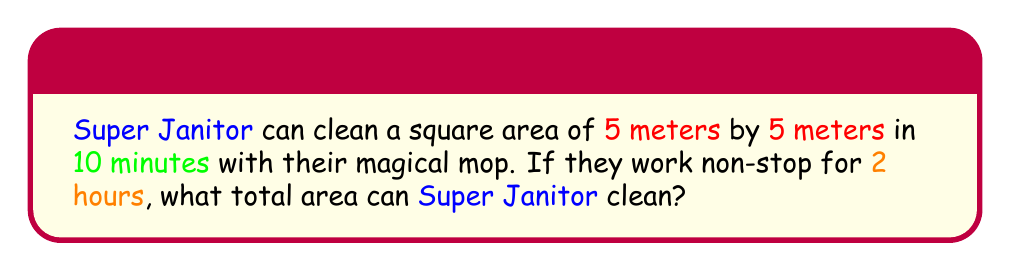Teach me how to tackle this problem. Let's break this down step-by-step:

1. First, we need to calculate the area Super Janitor can clean in 10 minutes:
   Area per 10 minutes = $5 \text{ m} \times 5 \text{ m} = 25 \text{ m}^2$

2. Now, let's convert 2 hours into minutes:
   $2 \text{ hours} = 2 \times 60 \text{ minutes} = 120 \text{ minutes}$

3. We need to find out how many 10-minute intervals are in 120 minutes:
   Number of intervals = $\frac{120 \text{ minutes}}{10 \text{ minutes per interval}} = 12 \text{ intervals}$

4. Now we can calculate the total area cleaned in 2 hours:
   Total area = Area per interval $\times$ Number of intervals
   $$ \text{Total area} = 25 \text{ m}^2 \times 12 = 300 \text{ m}^2 $$

Therefore, Super Janitor can clean an area of 300 square meters in 2 hours.
Answer: $300 \text{ m}^2$ 